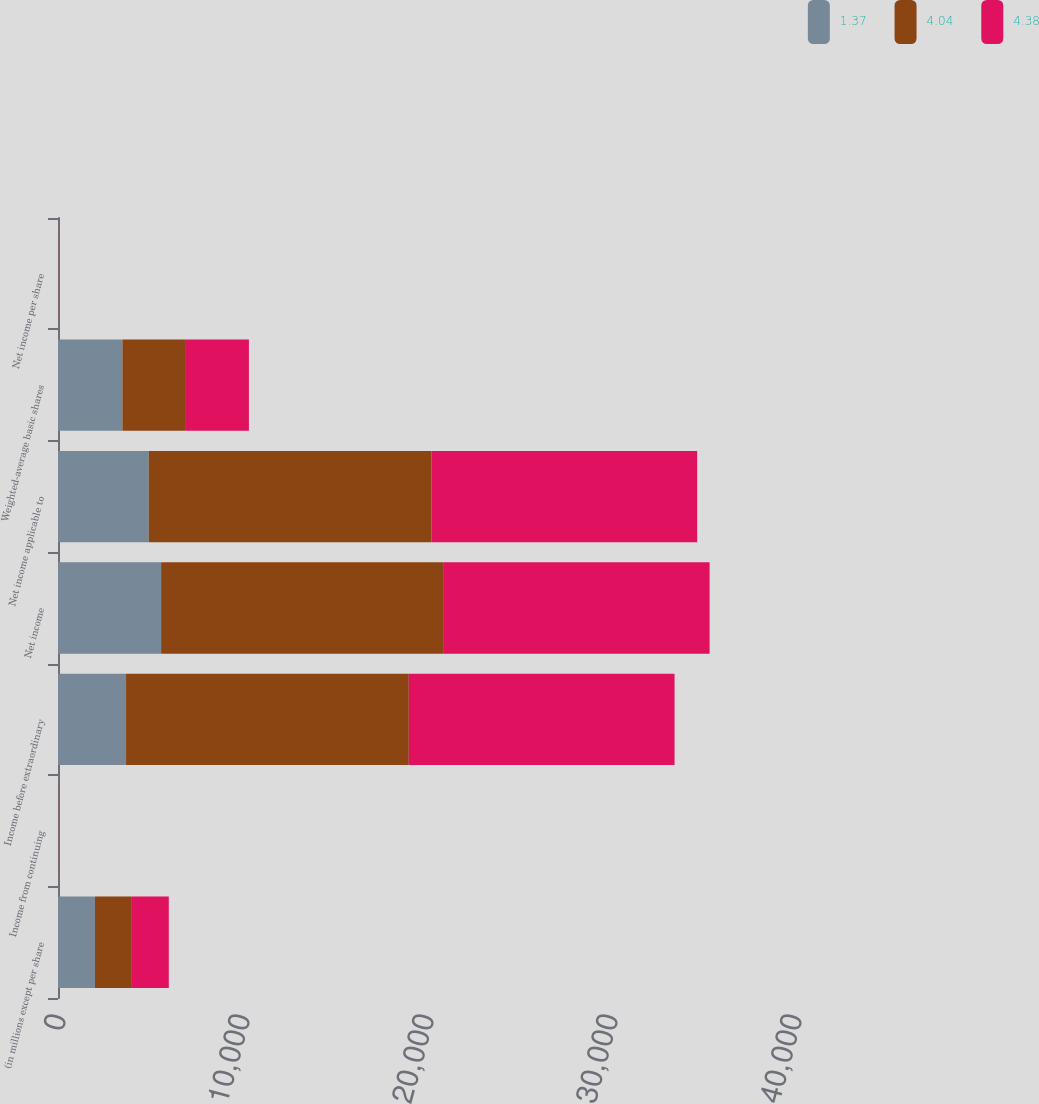<chart> <loc_0><loc_0><loc_500><loc_500><stacked_bar_chart><ecel><fcel>(in millions except per share<fcel>Income from continuing<fcel>Income before extraordinary<fcel>Net income<fcel>Net income applicable to<fcel>Weighted-average basic shares<fcel>Net income per share<nl><fcel>1.37<fcel>2008<fcel>0.86<fcel>3699<fcel>5605<fcel>4931<fcel>3501<fcel>1.41<nl><fcel>4.04<fcel>2007<fcel>4.51<fcel>15365<fcel>15365<fcel>15365<fcel>3404<fcel>4.51<nl><fcel>4.38<fcel>2006<fcel>3.93<fcel>14444<fcel>14444<fcel>14440<fcel>3470<fcel>4.16<nl></chart> 